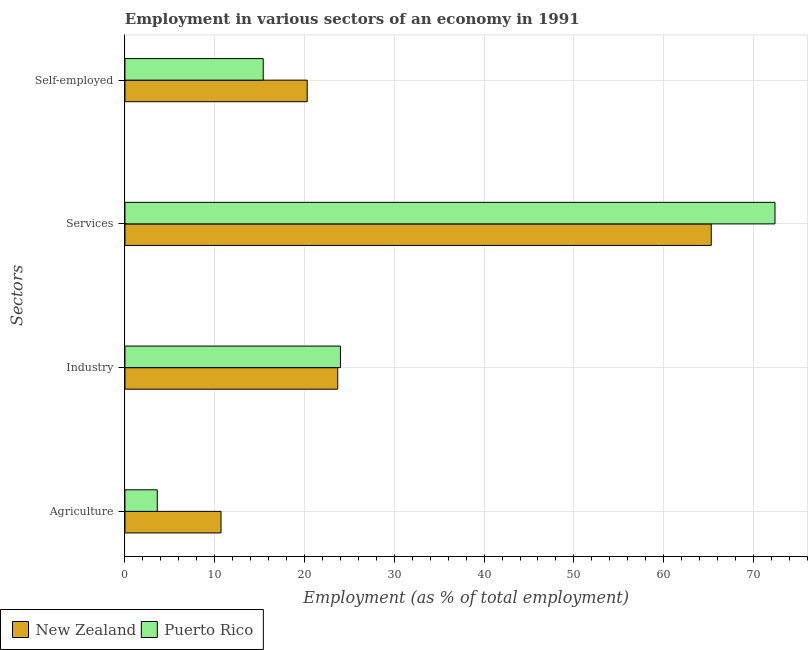Are the number of bars per tick equal to the number of legend labels?
Provide a succinct answer. Yes. Are the number of bars on each tick of the Y-axis equal?
Provide a succinct answer. Yes. How many bars are there on the 4th tick from the top?
Offer a very short reply. 2. What is the label of the 4th group of bars from the top?
Your answer should be compact. Agriculture. What is the percentage of self employed workers in Puerto Rico?
Ensure brevity in your answer.  15.4. Across all countries, what is the maximum percentage of workers in services?
Your response must be concise. 72.4. Across all countries, what is the minimum percentage of workers in industry?
Make the answer very short. 23.7. In which country was the percentage of workers in agriculture maximum?
Give a very brief answer. New Zealand. In which country was the percentage of workers in services minimum?
Keep it short and to the point. New Zealand. What is the total percentage of workers in agriculture in the graph?
Give a very brief answer. 14.3. What is the difference between the percentage of workers in industry in New Zealand and that in Puerto Rico?
Offer a terse response. -0.3. What is the difference between the percentage of workers in industry in New Zealand and the percentage of workers in services in Puerto Rico?
Offer a terse response. -48.7. What is the average percentage of workers in industry per country?
Your response must be concise. 23.85. What is the difference between the percentage of self employed workers and percentage of workers in services in Puerto Rico?
Give a very brief answer. -57. In how many countries, is the percentage of workers in services greater than 70 %?
Provide a succinct answer. 1. What is the ratio of the percentage of self employed workers in Puerto Rico to that in New Zealand?
Provide a short and direct response. 0.76. Is the percentage of workers in industry in Puerto Rico less than that in New Zealand?
Give a very brief answer. No. Is the difference between the percentage of workers in industry in New Zealand and Puerto Rico greater than the difference between the percentage of self employed workers in New Zealand and Puerto Rico?
Give a very brief answer. No. What is the difference between the highest and the second highest percentage of self employed workers?
Give a very brief answer. 4.9. What is the difference between the highest and the lowest percentage of self employed workers?
Your answer should be compact. 4.9. In how many countries, is the percentage of workers in industry greater than the average percentage of workers in industry taken over all countries?
Keep it short and to the point. 1. Is the sum of the percentage of workers in services in Puerto Rico and New Zealand greater than the maximum percentage of workers in industry across all countries?
Provide a succinct answer. Yes. Is it the case that in every country, the sum of the percentage of self employed workers and percentage of workers in services is greater than the sum of percentage of workers in agriculture and percentage of workers in industry?
Offer a very short reply. Yes. What does the 2nd bar from the top in Services represents?
Provide a short and direct response. New Zealand. What does the 1st bar from the bottom in Agriculture represents?
Your response must be concise. New Zealand. How many bars are there?
Make the answer very short. 8. Where does the legend appear in the graph?
Offer a terse response. Bottom left. How many legend labels are there?
Provide a short and direct response. 2. What is the title of the graph?
Your response must be concise. Employment in various sectors of an economy in 1991. What is the label or title of the X-axis?
Keep it short and to the point. Employment (as % of total employment). What is the label or title of the Y-axis?
Provide a short and direct response. Sectors. What is the Employment (as % of total employment) in New Zealand in Agriculture?
Your answer should be very brief. 10.7. What is the Employment (as % of total employment) in Puerto Rico in Agriculture?
Your answer should be very brief. 3.6. What is the Employment (as % of total employment) of New Zealand in Industry?
Give a very brief answer. 23.7. What is the Employment (as % of total employment) of Puerto Rico in Industry?
Make the answer very short. 24. What is the Employment (as % of total employment) in New Zealand in Services?
Provide a succinct answer. 65.3. What is the Employment (as % of total employment) of Puerto Rico in Services?
Your answer should be very brief. 72.4. What is the Employment (as % of total employment) of New Zealand in Self-employed?
Your answer should be compact. 20.3. What is the Employment (as % of total employment) in Puerto Rico in Self-employed?
Keep it short and to the point. 15.4. Across all Sectors, what is the maximum Employment (as % of total employment) in New Zealand?
Offer a terse response. 65.3. Across all Sectors, what is the maximum Employment (as % of total employment) in Puerto Rico?
Your answer should be very brief. 72.4. Across all Sectors, what is the minimum Employment (as % of total employment) in New Zealand?
Keep it short and to the point. 10.7. Across all Sectors, what is the minimum Employment (as % of total employment) in Puerto Rico?
Your response must be concise. 3.6. What is the total Employment (as % of total employment) of New Zealand in the graph?
Your answer should be very brief. 120. What is the total Employment (as % of total employment) of Puerto Rico in the graph?
Your answer should be compact. 115.4. What is the difference between the Employment (as % of total employment) in Puerto Rico in Agriculture and that in Industry?
Your answer should be compact. -20.4. What is the difference between the Employment (as % of total employment) in New Zealand in Agriculture and that in Services?
Your answer should be compact. -54.6. What is the difference between the Employment (as % of total employment) in Puerto Rico in Agriculture and that in Services?
Your answer should be very brief. -68.8. What is the difference between the Employment (as % of total employment) in New Zealand in Agriculture and that in Self-employed?
Provide a succinct answer. -9.6. What is the difference between the Employment (as % of total employment) of New Zealand in Industry and that in Services?
Keep it short and to the point. -41.6. What is the difference between the Employment (as % of total employment) in Puerto Rico in Industry and that in Services?
Keep it short and to the point. -48.4. What is the difference between the Employment (as % of total employment) in New Zealand in Industry and that in Self-employed?
Your response must be concise. 3.4. What is the difference between the Employment (as % of total employment) in Puerto Rico in Services and that in Self-employed?
Provide a short and direct response. 57. What is the difference between the Employment (as % of total employment) of New Zealand in Agriculture and the Employment (as % of total employment) of Puerto Rico in Industry?
Provide a succinct answer. -13.3. What is the difference between the Employment (as % of total employment) of New Zealand in Agriculture and the Employment (as % of total employment) of Puerto Rico in Services?
Ensure brevity in your answer.  -61.7. What is the difference between the Employment (as % of total employment) in New Zealand in Agriculture and the Employment (as % of total employment) in Puerto Rico in Self-employed?
Your response must be concise. -4.7. What is the difference between the Employment (as % of total employment) in New Zealand in Industry and the Employment (as % of total employment) in Puerto Rico in Services?
Ensure brevity in your answer.  -48.7. What is the difference between the Employment (as % of total employment) of New Zealand in Industry and the Employment (as % of total employment) of Puerto Rico in Self-employed?
Your response must be concise. 8.3. What is the difference between the Employment (as % of total employment) of New Zealand in Services and the Employment (as % of total employment) of Puerto Rico in Self-employed?
Give a very brief answer. 49.9. What is the average Employment (as % of total employment) in Puerto Rico per Sectors?
Offer a terse response. 28.85. What is the difference between the Employment (as % of total employment) in New Zealand and Employment (as % of total employment) in Puerto Rico in Industry?
Your answer should be very brief. -0.3. What is the difference between the Employment (as % of total employment) in New Zealand and Employment (as % of total employment) in Puerto Rico in Services?
Your answer should be compact. -7.1. What is the ratio of the Employment (as % of total employment) of New Zealand in Agriculture to that in Industry?
Provide a short and direct response. 0.45. What is the ratio of the Employment (as % of total employment) in Puerto Rico in Agriculture to that in Industry?
Provide a short and direct response. 0.15. What is the ratio of the Employment (as % of total employment) in New Zealand in Agriculture to that in Services?
Offer a very short reply. 0.16. What is the ratio of the Employment (as % of total employment) of Puerto Rico in Agriculture to that in Services?
Your response must be concise. 0.05. What is the ratio of the Employment (as % of total employment) of New Zealand in Agriculture to that in Self-employed?
Offer a terse response. 0.53. What is the ratio of the Employment (as % of total employment) of Puerto Rico in Agriculture to that in Self-employed?
Give a very brief answer. 0.23. What is the ratio of the Employment (as % of total employment) in New Zealand in Industry to that in Services?
Give a very brief answer. 0.36. What is the ratio of the Employment (as % of total employment) in Puerto Rico in Industry to that in Services?
Ensure brevity in your answer.  0.33. What is the ratio of the Employment (as % of total employment) in New Zealand in Industry to that in Self-employed?
Give a very brief answer. 1.17. What is the ratio of the Employment (as % of total employment) in Puerto Rico in Industry to that in Self-employed?
Ensure brevity in your answer.  1.56. What is the ratio of the Employment (as % of total employment) of New Zealand in Services to that in Self-employed?
Offer a terse response. 3.22. What is the ratio of the Employment (as % of total employment) of Puerto Rico in Services to that in Self-employed?
Your answer should be compact. 4.7. What is the difference between the highest and the second highest Employment (as % of total employment) in New Zealand?
Offer a terse response. 41.6. What is the difference between the highest and the second highest Employment (as % of total employment) of Puerto Rico?
Offer a terse response. 48.4. What is the difference between the highest and the lowest Employment (as % of total employment) of New Zealand?
Keep it short and to the point. 54.6. What is the difference between the highest and the lowest Employment (as % of total employment) of Puerto Rico?
Keep it short and to the point. 68.8. 